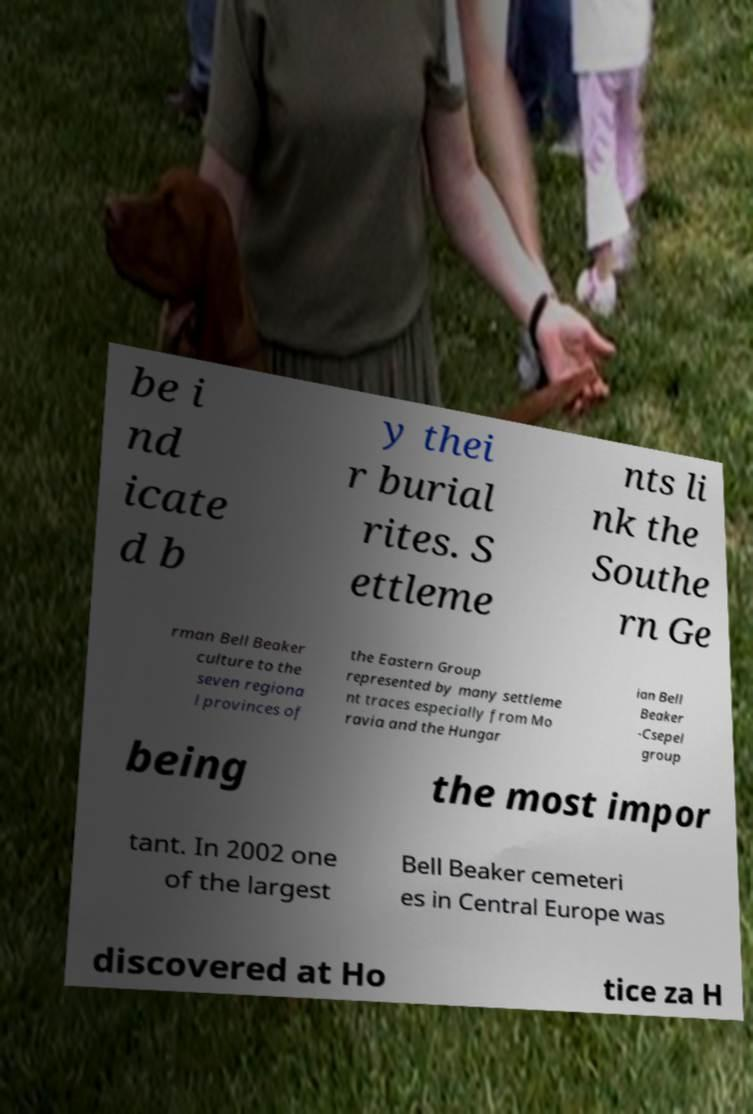Can you read and provide the text displayed in the image?This photo seems to have some interesting text. Can you extract and type it out for me? be i nd icate d b y thei r burial rites. S ettleme nts li nk the Southe rn Ge rman Bell Beaker culture to the seven regiona l provinces of the Eastern Group represented by many settleme nt traces especially from Mo ravia and the Hungar ian Bell Beaker -Csepel group being the most impor tant. In 2002 one of the largest Bell Beaker cemeteri es in Central Europe was discovered at Ho tice za H 